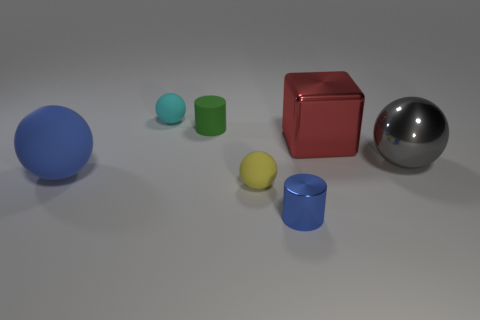Subtract all balls. How many objects are left? 3 Subtract 1 blocks. How many blocks are left? 0 Subtract all cyan cylinders. Subtract all gray cubes. How many cylinders are left? 2 Subtract all brown spheres. How many green cylinders are left? 1 Subtract all tiny blue things. Subtract all cubes. How many objects are left? 5 Add 2 green rubber cylinders. How many green rubber cylinders are left? 3 Add 5 green objects. How many green objects exist? 6 Add 3 cyan cubes. How many objects exist? 10 Subtract all green cylinders. How many cylinders are left? 1 Subtract all rubber balls. How many balls are left? 1 